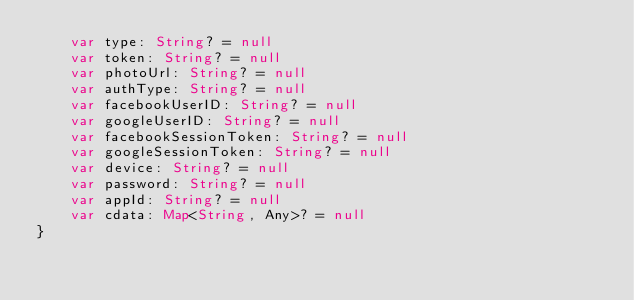Convert code to text. <code><loc_0><loc_0><loc_500><loc_500><_Kotlin_>    var type: String? = null
    var token: String? = null
    var photoUrl: String? = null
    var authType: String? = null
    var facebookUserID: String? = null
    var googleUserID: String? = null
    var facebookSessionToken: String? = null
    var googleSessionToken: String? = null
    var device: String? = null
    var password: String? = null
    var appId: String? = null
    var cdata: Map<String, Any>? = null
}
</code> 